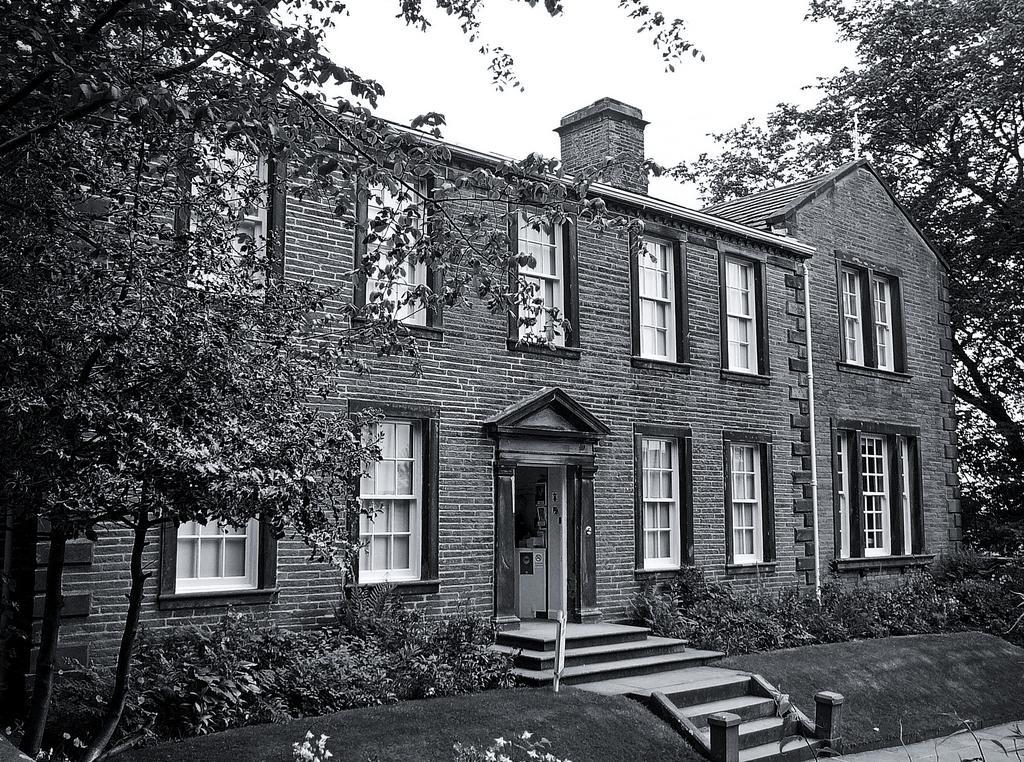Could you give a brief overview of what you see in this image? In the picture we can see a building with windows, door and near the door, we can see some steps and besides it, we can see some plants on the grass surface and besides the building we can see trees and in the background we can see a sky. 